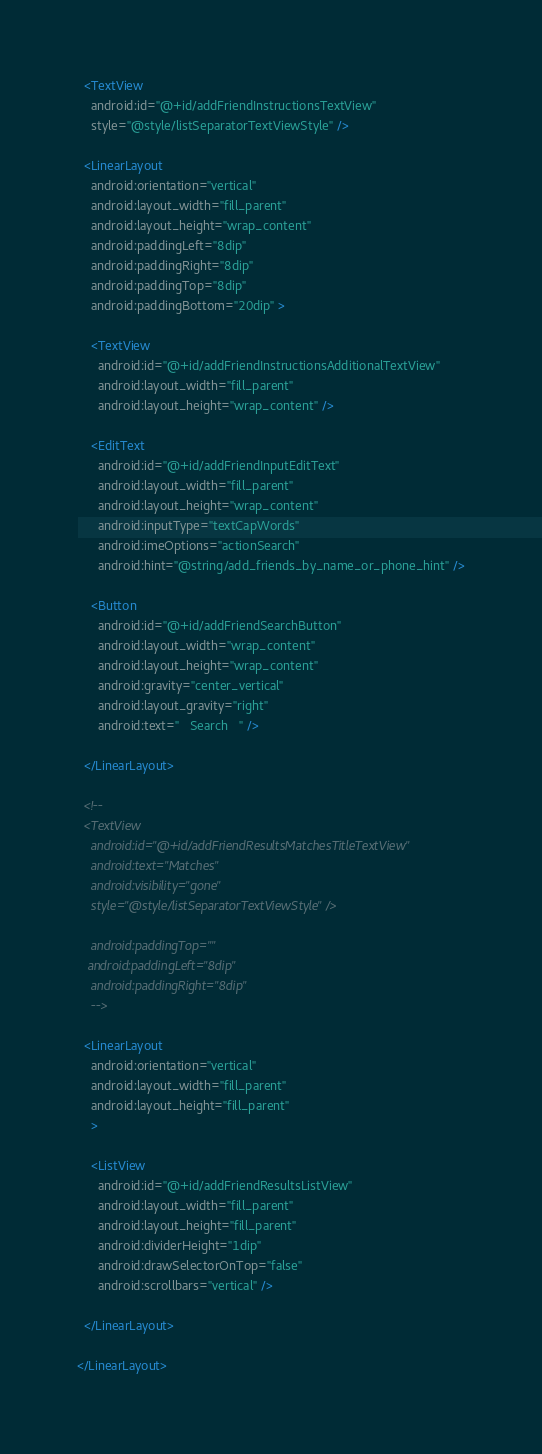Convert code to text. <code><loc_0><loc_0><loc_500><loc_500><_XML_>  <TextView
    android:id="@+id/addFriendInstructionsTextView"
    style="@style/listSeparatorTextViewStyle" />
      
  <LinearLayout
    android:orientation="vertical" 
    android:layout_width="fill_parent"
    android:layout_height="wrap_content"
    android:paddingLeft="8dip"
    android:paddingRight="8dip"
    android:paddingTop="8dip"
    android:paddingBottom="20dip" >
  
    <TextView
      android:id="@+id/addFriendInstructionsAdditionalTextView"
      android:layout_width="fill_parent"
      android:layout_height="wrap_content" />
  
    <EditText
      android:id="@+id/addFriendInputEditText"
      android:layout_width="fill_parent"
      android:layout_height="wrap_content"
      android:inputType="textCapWords"
      android:imeOptions="actionSearch"
      android:hint="@string/add_friends_by_name_or_phone_hint" />
     
    <Button
      android:id="@+id/addFriendSearchButton"
      android:layout_width="wrap_content"
      android:layout_height="wrap_content"
      android:gravity="center_vertical"
      android:layout_gravity="right" 
      android:text="   Search   " />
      
  </LinearLayout>

  <!-- 
  <TextView
    android:id="@+id/addFriendResultsMatchesTitleTextView"
    android:text="Matches"  
    android:visibility="gone"
    style="@style/listSeparatorTextViewStyle" />
  
    android:paddingTop=""
   android:paddingLeft="8dip"
    android:paddingRight="8dip"
    -->
     
  <LinearLayout
    android:orientation="vertical" 
    android:layout_width="fill_parent"
    android:layout_height="fill_parent"
    >
   
    <ListView
      android:id="@+id/addFriendResultsListView"
      android:layout_width="fill_parent"
      android:layout_height="fill_parent"
      android:dividerHeight="1dip" 
      android:drawSelectorOnTop="false"
      android:scrollbars="vertical" />
    
  </LinearLayout>
  
</LinearLayout></code> 